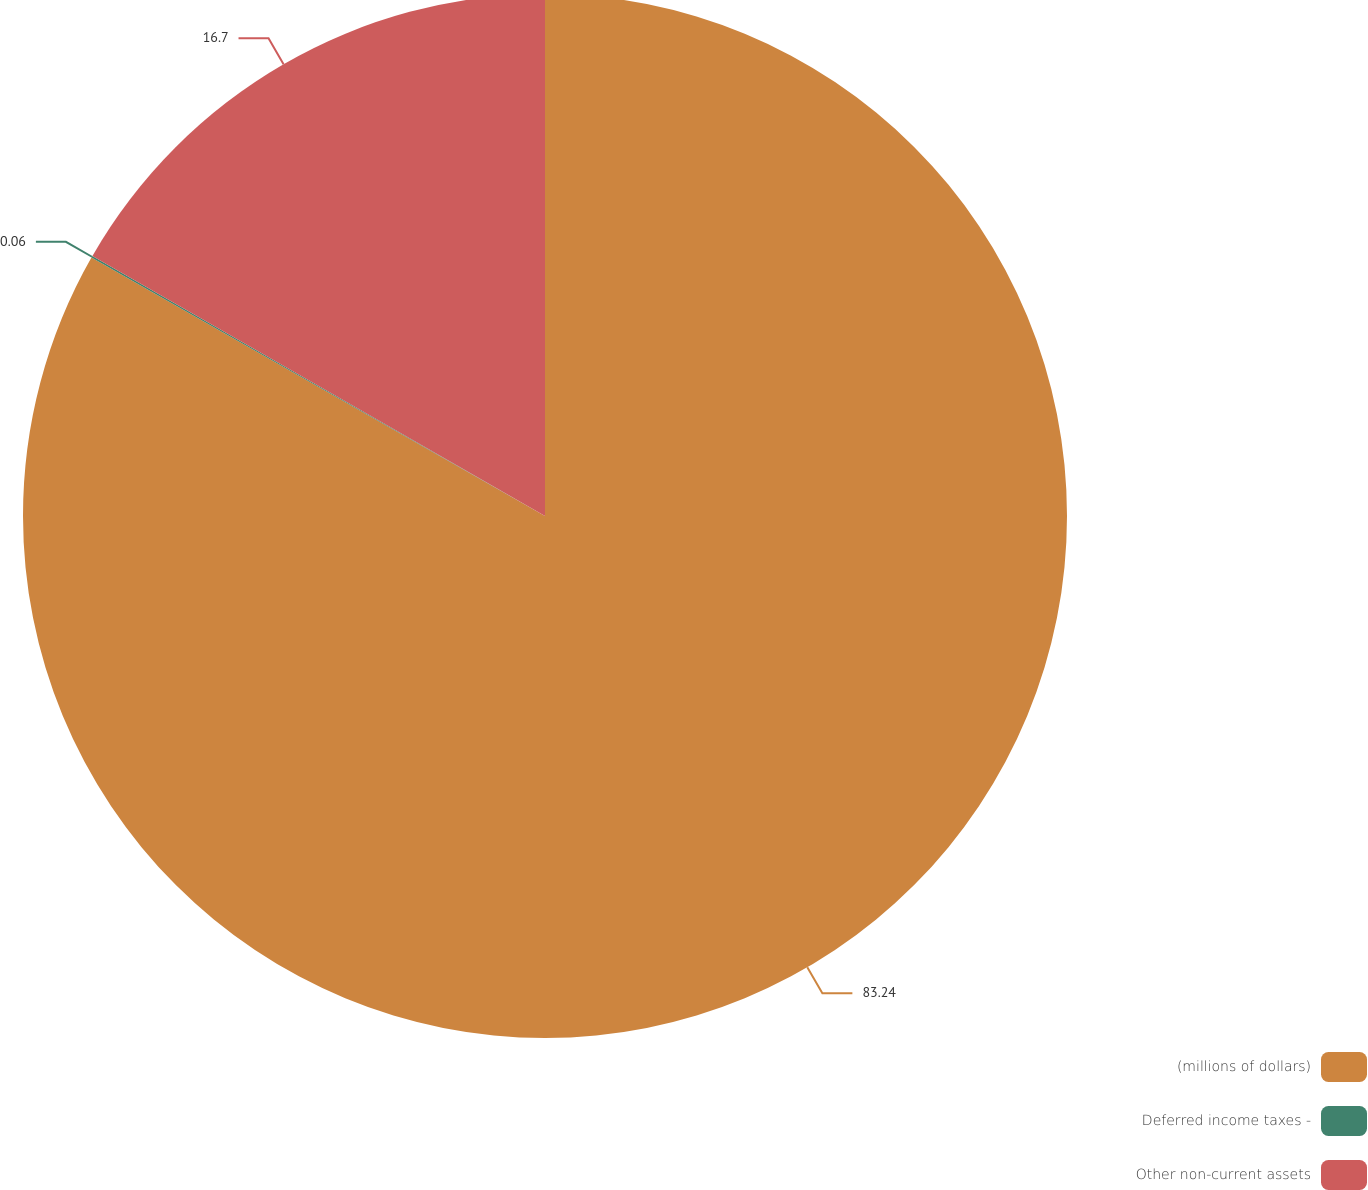Convert chart. <chart><loc_0><loc_0><loc_500><loc_500><pie_chart><fcel>(millions of dollars)<fcel>Deferred income taxes -<fcel>Other non-current assets<nl><fcel>83.25%<fcel>0.06%<fcel>16.7%<nl></chart> 